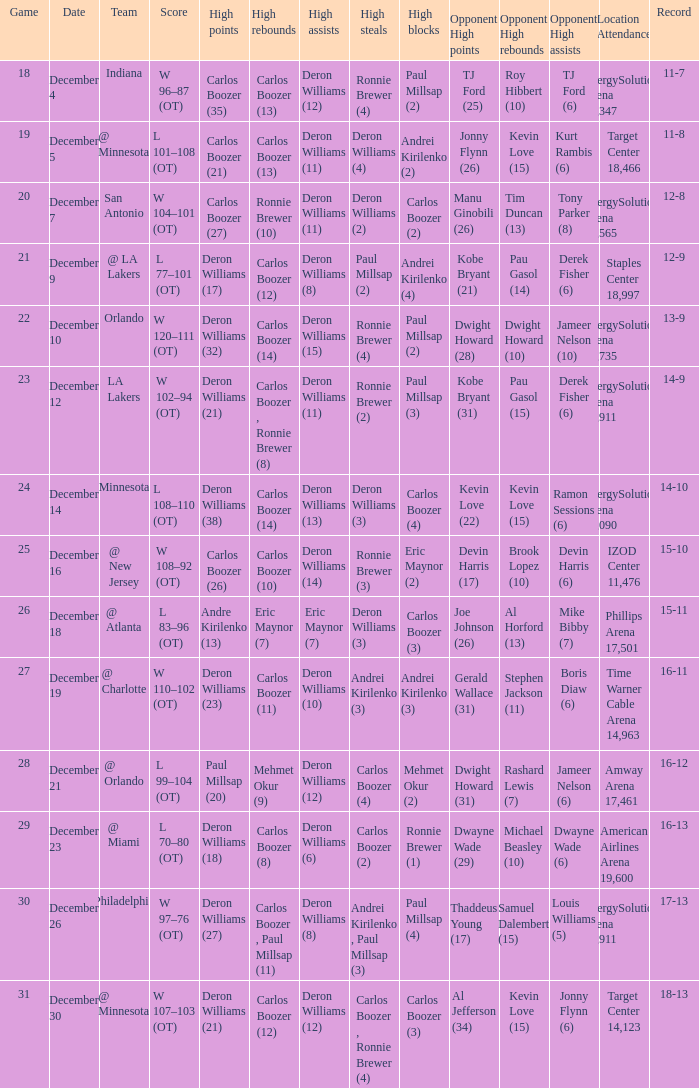What's the number of the game in which Carlos Boozer (8) did the high rebounds? 29.0. 